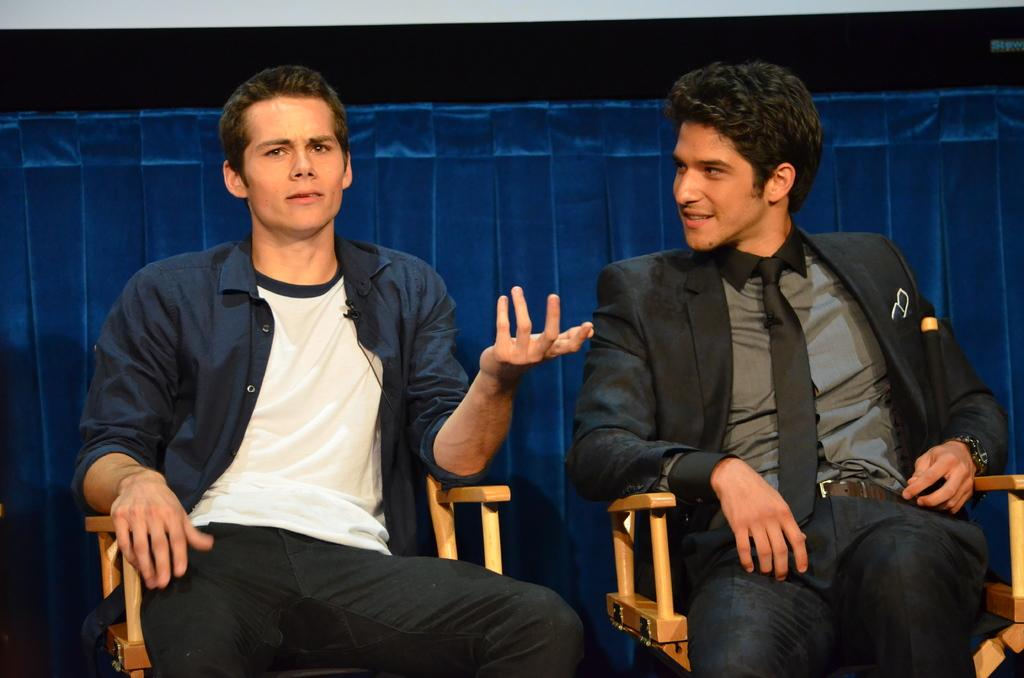How many people are in the image? There are two men in the image. What are the men doing in the image? Both men are sitting on chairs. Can you describe the clothing of the first man? The first man is wearing a suit. How about the clothing of the second man? The second man is wearing a blue color shirt. What can be seen in the background of the image? There are blue color things visible in the background. What type of powder is being used by the men in the image? There is no powder visible in the image; both men are simply sitting on chairs. 